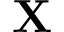Convert formula to latex. <formula><loc_0><loc_0><loc_500><loc_500>X</formula> 